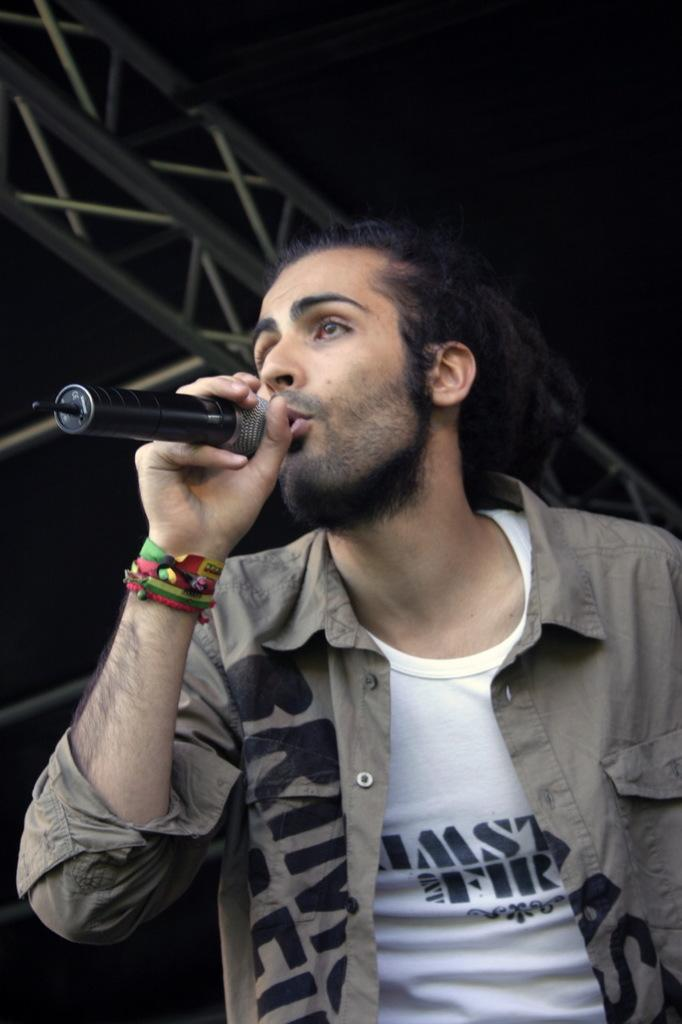Who is the main subject in the image? There is a man in the image. What is the man wearing? The man is wearing a shirt. What is the man holding in his hand? The man is holding a microphone in his hand. What is the man doing in the image? The man is singing. Where is the image taken? The image is an outside view. What type of glove is the man wearing in the image? The man is not wearing a glove in the image; he is wearing a shirt. How does the heat affect the man in the image? The provided facts do not mention any heat or its effect on the man in the image. 